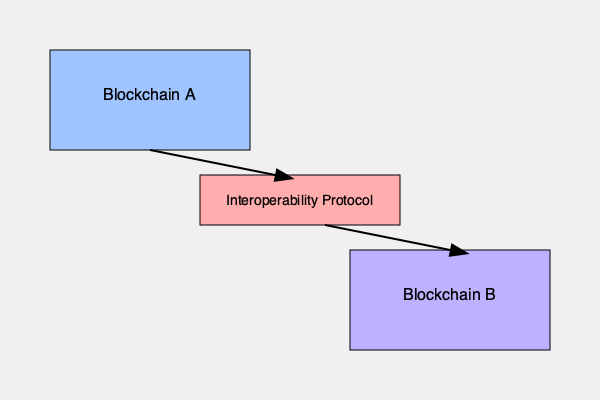In the context of blockchain interoperability, explain the concept of atomic swaps and how they facilitate cross-chain asset transfers. How does this differ from other interoperability protocols, such as sidechains or relay chains? Provide an example of how an atomic swap would work between Blockchain A and Blockchain B in the diagram. To understand atomic swaps and their role in blockchain interoperability, let's break down the concept and compare it to other protocols:

1. Atomic Swaps:
   - Definition: Atomic swaps are peer-to-peer exchanges of cryptocurrencies between different blockchains without the need for intermediaries.
   - Key feature: They use Hash Timelock Contracts (HTLCs) to ensure that either both parties receive their assets or neither does.

2. How Atomic Swaps Work:
   a) User A initiates the swap by creating an HTLC on Blockchain A with a secret key.
   b) User B creates a corresponding HTLC on Blockchain B.
   c) User A reveals the secret key to claim the assets on Blockchain B.
   d) User B uses the revealed secret to claim the assets on Blockchain A.
   e) If either party fails to complete the swap within the specified timeframe, the assets return to their original owners.

3. Comparison with Other Interoperability Protocols:
   - Sidechains: Separate blockchains connected to a main chain, allowing assets to move between them. Unlike atomic swaps, sidechains require trust in the sidechain operators.
   - Relay Chains: Act as intermediaries between multiple blockchains, facilitating communication and asset transfers. Examples include Polkadot and Cosmos. Relay chains require a more complex infrastructure compared to atomic swaps.

4. Example of an Atomic Swap between Blockchain A and B:
   Let's say User X on Blockchain A wants to exchange 1 CoinA for 10 CoinB with User Y on Blockchain B.
   
   a) User X creates an HTLC on Blockchain A, locking 1 CoinA with a secret key.
   b) User Y creates an HTLC on Blockchain B, locking 10 CoinB with the same secret key hash.
   c) User X reveals the secret key to claim 10 CoinB on Blockchain B.
   d) User Y uses the revealed secret to claim 1 CoinA on Blockchain A.

   The interoperability protocol in the diagram would facilitate this process by providing the necessary infrastructure for creating and executing HTLCs across both blockchains.

5. Advantages of Atomic Swaps:
   - Trustless: No need for intermediaries or centralized exchanges.
   - Security: The HTLC mechanism ensures that either both parties receive their assets or the swap is cancelled.
   - Cross-chain compatibility: Enables direct exchanges between different blockchain networks.

6. Limitations:
   - Requires both blockchains to support the same cryptographic hash function.
   - May have higher transaction fees due to the complexity of the smart contracts involved.
   - Limited to simple asset exchanges and not suitable for more complex cross-chain operations.
Answer: Atomic swaps use Hash Timelock Contracts for trustless peer-to-peer cross-chain asset exchanges, differing from sidechains and relay chains by eliminating intermediaries and complex infrastructure. 